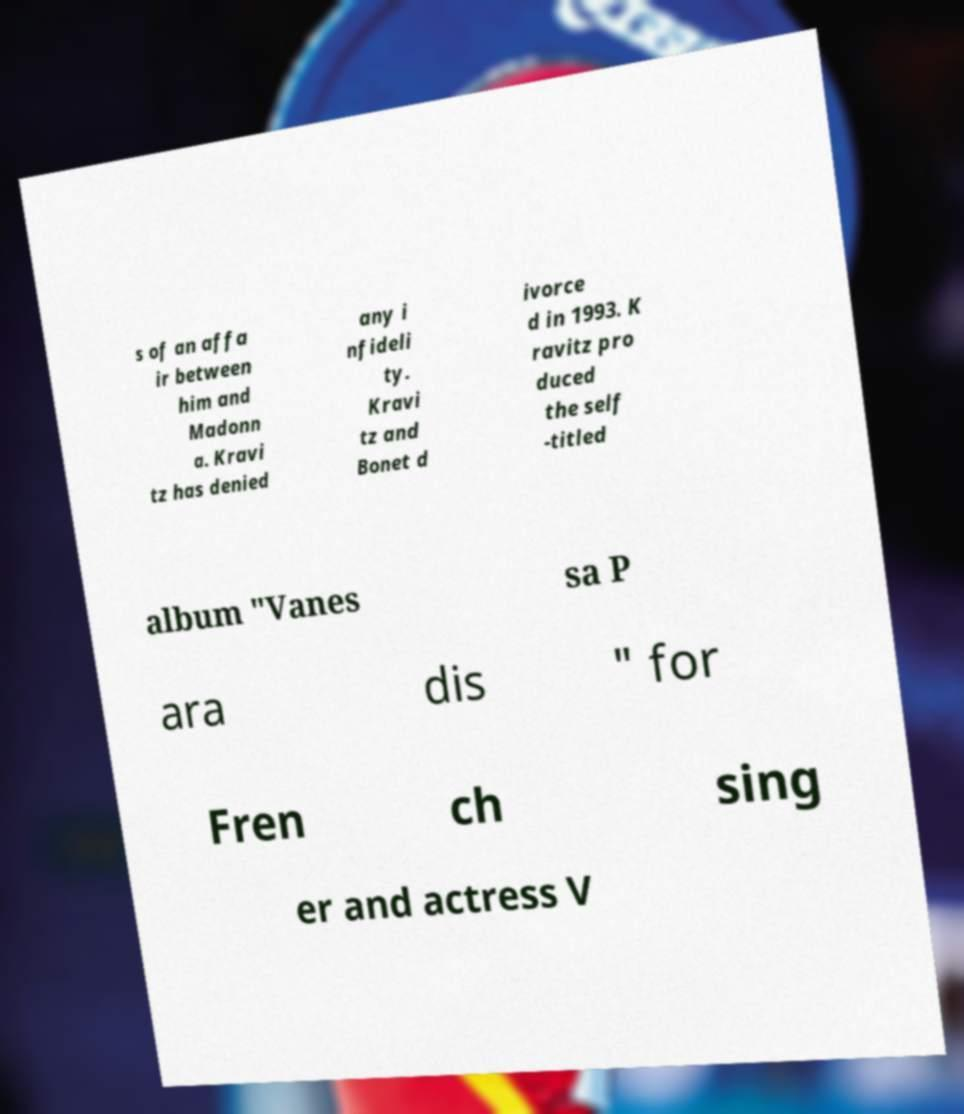Can you read and provide the text displayed in the image?This photo seems to have some interesting text. Can you extract and type it out for me? s of an affa ir between him and Madonn a. Kravi tz has denied any i nfideli ty. Kravi tz and Bonet d ivorce d in 1993. K ravitz pro duced the self -titled album "Vanes sa P ara dis " for Fren ch sing er and actress V 